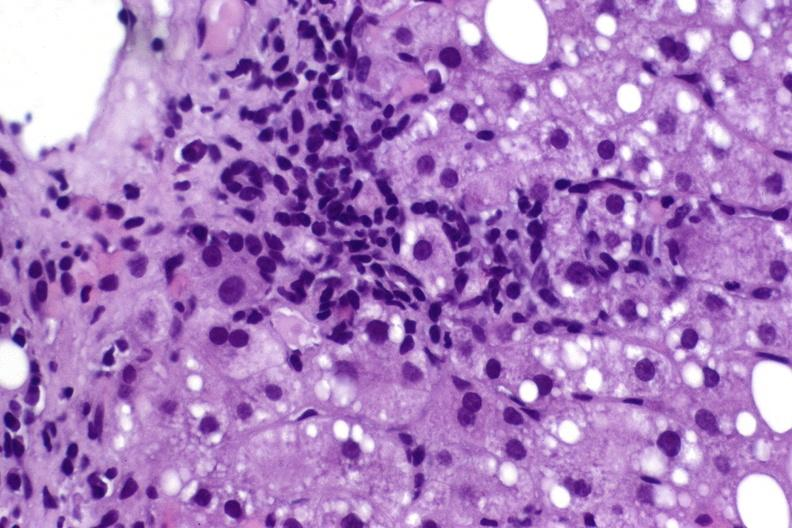s liver present?
Answer the question using a single word or phrase. Yes 